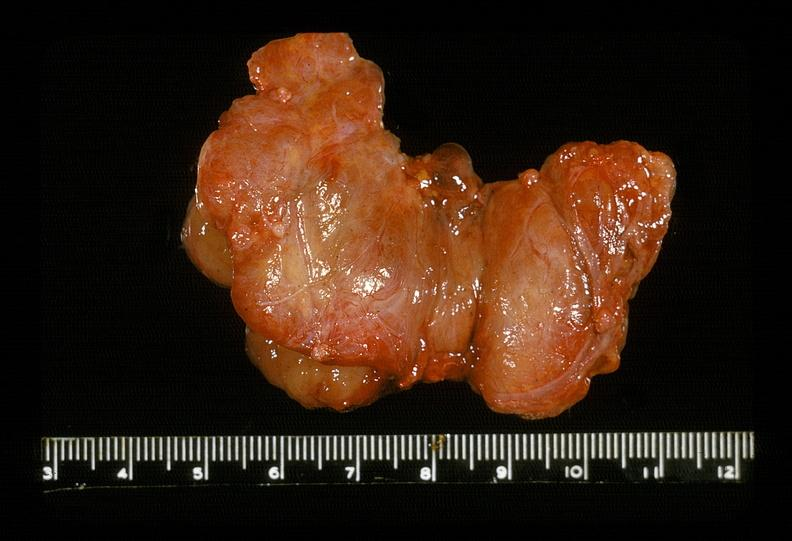s endocrine present?
Answer the question using a single word or phrase. Yes 